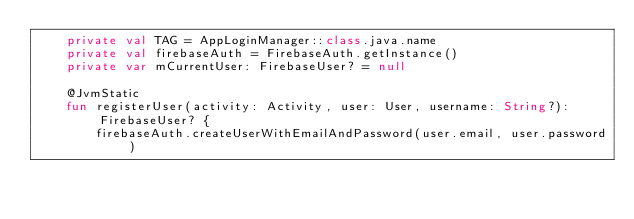<code> <loc_0><loc_0><loc_500><loc_500><_Kotlin_>    private val TAG = AppLoginManager::class.java.name
    private val firebaseAuth = FirebaseAuth.getInstance()
    private var mCurrentUser: FirebaseUser? = null

    @JvmStatic
    fun registerUser(activity: Activity, user: User, username: String?): FirebaseUser? {
        firebaseAuth.createUserWithEmailAndPassword(user.email, user.password)</code> 